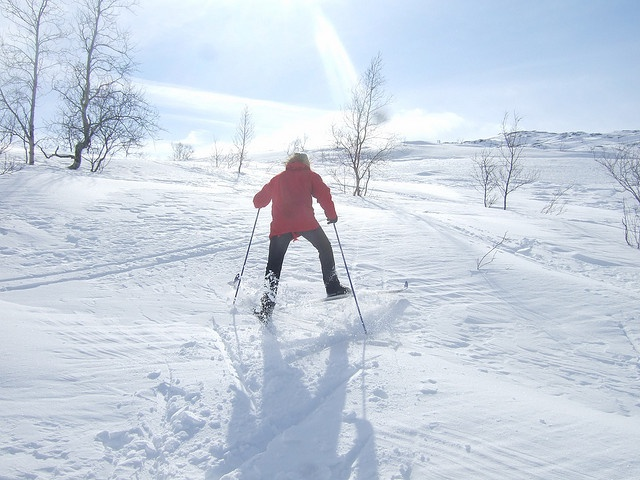Describe the objects in this image and their specific colors. I can see people in lightgray, brown, gray, and black tones and skis in lightgray, darkgray, and gray tones in this image. 